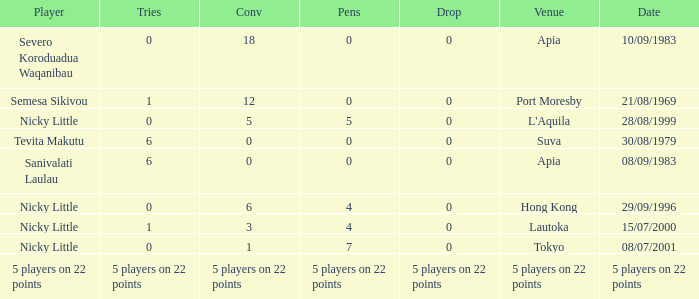Parse the table in full. {'header': ['Player', 'Tries', 'Conv', 'Pens', 'Drop', 'Venue', 'Date'], 'rows': [['Severo Koroduadua Waqanibau', '0', '18', '0', '0', 'Apia', '10/09/1983'], ['Semesa Sikivou', '1', '12', '0', '0', 'Port Moresby', '21/08/1969'], ['Nicky Little', '0', '5', '5', '0', "L'Aquila", '28/08/1999'], ['Tevita Makutu', '6', '0', '0', '0', 'Suva', '30/08/1979'], ['Sanivalati Laulau', '6', '0', '0', '0', 'Apia', '08/09/1983'], ['Nicky Little', '0', '6', '4', '0', 'Hong Kong', '29/09/1996'], ['Nicky Little', '1', '3', '4', '0', 'Lautoka', '15/07/2000'], ['Nicky Little', '0', '1', '7', '0', 'Tokyo', '08/07/2001'], ['5 players on 22 points', '5 players on 22 points', '5 players on 22 points', '5 players on 22 points', '5 players on 22 points', '5 players on 22 points', '5 players on 22 points']]} What is the count of drops nicky little experienced in hong kong? 0.0. 